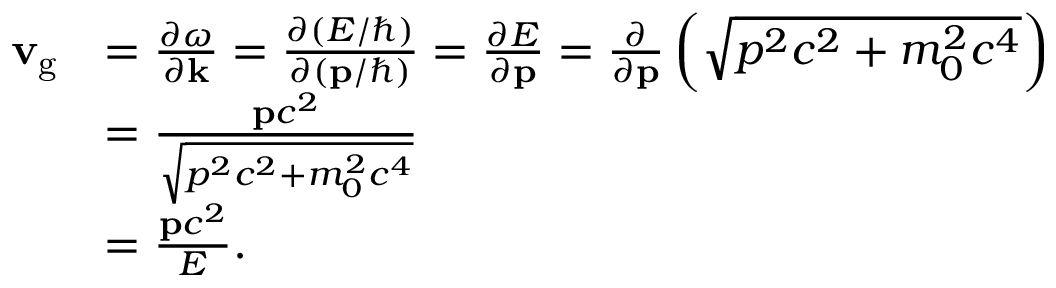<formula> <loc_0><loc_0><loc_500><loc_500>{ \begin{array} { r l } { v _ { g } } & { = { \frac { \partial \omega } { \partial k } } = { \frac { \partial ( E / \hbar { ) } } { \partial ( p / \hbar { ) } } } = { \frac { \partial E } { \partial p } } = { \frac { \partial } { \partial p } } \left ( { \sqrt { p ^ { 2 } c ^ { 2 } + m _ { 0 } ^ { 2 } c ^ { 4 } } } \right ) } \\ & { = { \frac { p c ^ { 2 } } { \sqrt { p ^ { 2 } c ^ { 2 } + m _ { 0 } ^ { 2 } c ^ { 4 } } } } } \\ & { = { \frac { p c ^ { 2 } } { E } } . } \end{array} }</formula> 